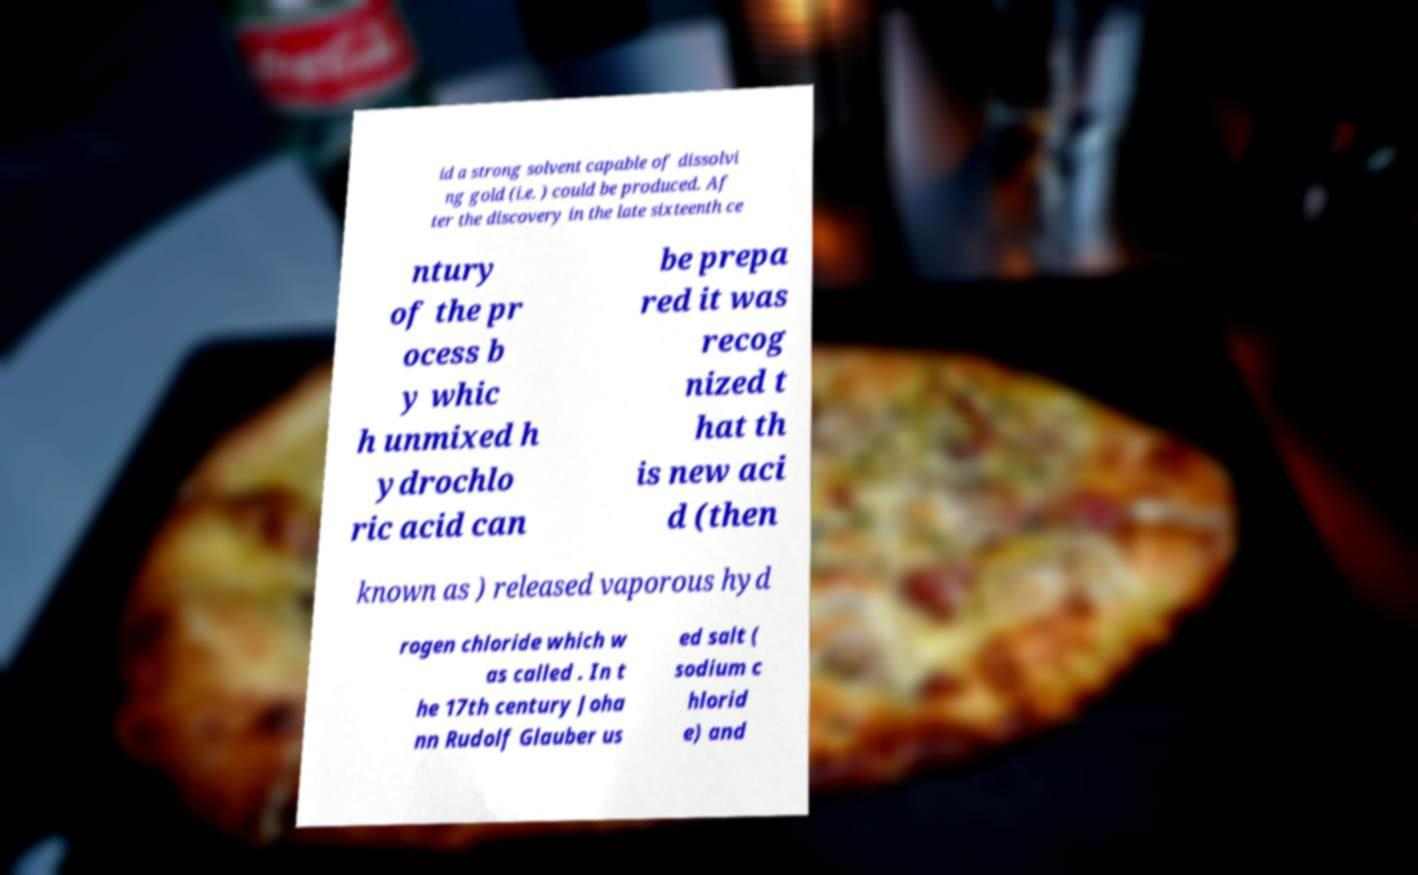Can you accurately transcribe the text from the provided image for me? id a strong solvent capable of dissolvi ng gold (i.e. ) could be produced. Af ter the discovery in the late sixteenth ce ntury of the pr ocess b y whic h unmixed h ydrochlo ric acid can be prepa red it was recog nized t hat th is new aci d (then known as ) released vaporous hyd rogen chloride which w as called . In t he 17th century Joha nn Rudolf Glauber us ed salt ( sodium c hlorid e) and 